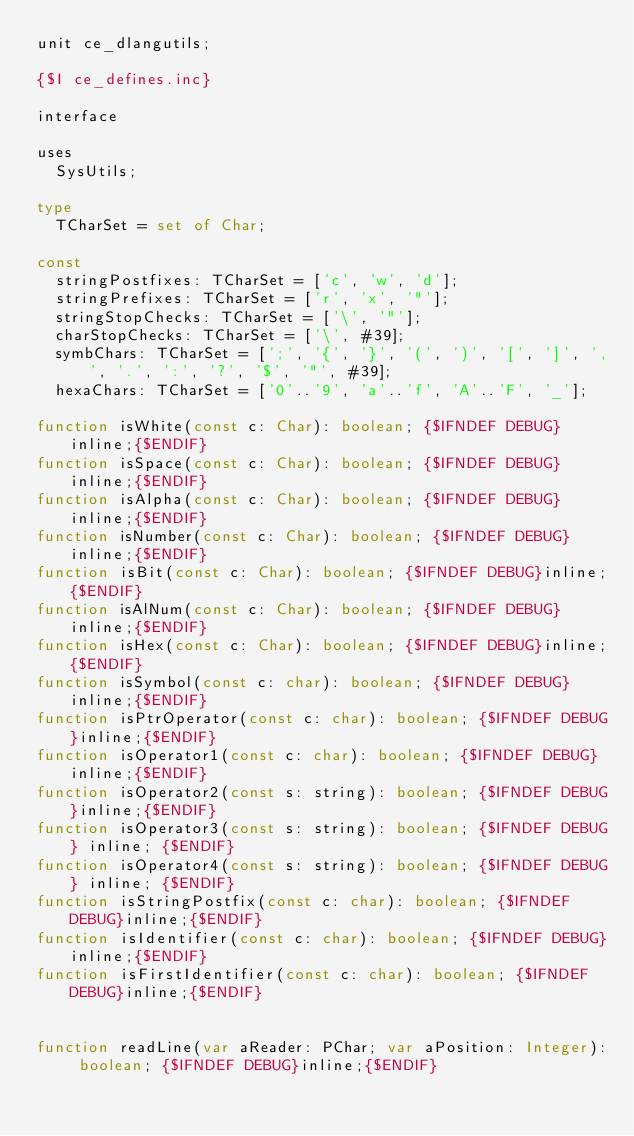Convert code to text. <code><loc_0><loc_0><loc_500><loc_500><_Pascal_>unit ce_dlangutils;

{$I ce_defines.inc}

interface

uses
  SysUtils;

type
  TCharSet = set of Char;

const
  stringPostfixes: TCharSet = ['c', 'w', 'd'];
  stringPrefixes: TCharSet = ['r', 'x', '"'];
  stringStopChecks: TCharSet = ['\', '"'];
  charStopChecks: TCharSet = ['\', #39];
  symbChars: TCharSet = [';', '{', '}', '(', ')', '[', ']', ',', '.', ':', '?', '$', '"', #39];
  hexaChars: TCharSet = ['0'..'9', 'a'..'f', 'A'..'F', '_'];

function isWhite(const c: Char): boolean; {$IFNDEF DEBUG}inline;{$ENDIF}
function isSpace(const c: Char): boolean; {$IFNDEF DEBUG}inline;{$ENDIF}
function isAlpha(const c: Char): boolean; {$IFNDEF DEBUG}inline;{$ENDIF}
function isNumber(const c: Char): boolean; {$IFNDEF DEBUG}inline;{$ENDIF}
function isBit(const c: Char): boolean; {$IFNDEF DEBUG}inline;{$ENDIF}
function isAlNum(const c: Char): boolean; {$IFNDEF DEBUG}inline;{$ENDIF}
function isHex(const c: Char): boolean; {$IFNDEF DEBUG}inline;{$ENDIF}
function isSymbol(const c: char): boolean; {$IFNDEF DEBUG}inline;{$ENDIF}
function isPtrOperator(const c: char): boolean; {$IFNDEF DEBUG}inline;{$ENDIF}
function isOperator1(const c: char): boolean; {$IFNDEF DEBUG}inline;{$ENDIF}
function isOperator2(const s: string): boolean; {$IFNDEF DEBUG}inline;{$ENDIF}
function isOperator3(const s: string): boolean; {$IFNDEF DEBUG} inline; {$ENDIF}
function isOperator4(const s: string): boolean; {$IFNDEF DEBUG} inline; {$ENDIF}
function isStringPostfix(const c: char): boolean; {$IFNDEF DEBUG}inline;{$ENDIF}
function isIdentifier(const c: char): boolean; {$IFNDEF DEBUG}inline;{$ENDIF}
function isFirstIdentifier(const c: char): boolean; {$IFNDEF DEBUG}inline;{$ENDIF}


function readLine(var aReader: PChar; var aPosition: Integer): boolean; {$IFNDEF DEBUG}inline;{$ENDIF}
</code> 